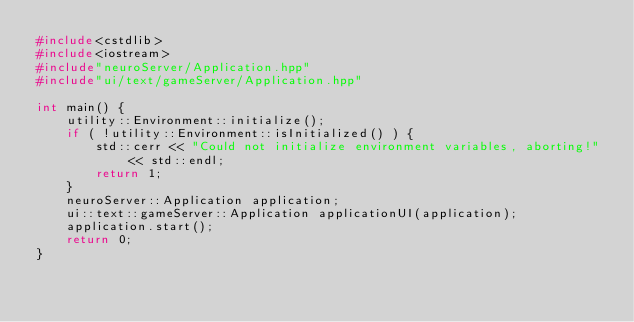Convert code to text. <code><loc_0><loc_0><loc_500><loc_500><_C++_>#include<cstdlib>
#include<iostream>
#include"neuroServer/Application.hpp"
#include"ui/text/gameServer/Application.hpp"

int main() {
	utility::Environment::initialize();
	if ( !utility::Environment::isInitialized() ) {
		std::cerr << "Could not initialize environment variables, aborting!" << std::endl;
		return 1;
	}
	neuroServer::Application application;
	ui::text::gameServer::Application applicationUI(application);
	application.start();
	return 0;
}
</code> 